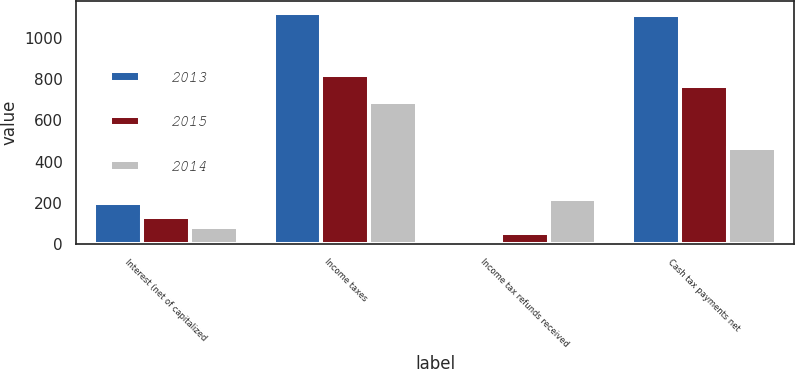<chart> <loc_0><loc_0><loc_500><loc_500><stacked_bar_chart><ecel><fcel>Interest (net of capitalized<fcel>Income taxes<fcel>Income tax refunds received<fcel>Cash tax payments net<nl><fcel>2013<fcel>201<fcel>1122<fcel>9<fcel>1113<nl><fcel>2015<fcel>131<fcel>820<fcel>54<fcel>766<nl><fcel>2014<fcel>80<fcel>687<fcel>219<fcel>468<nl></chart> 